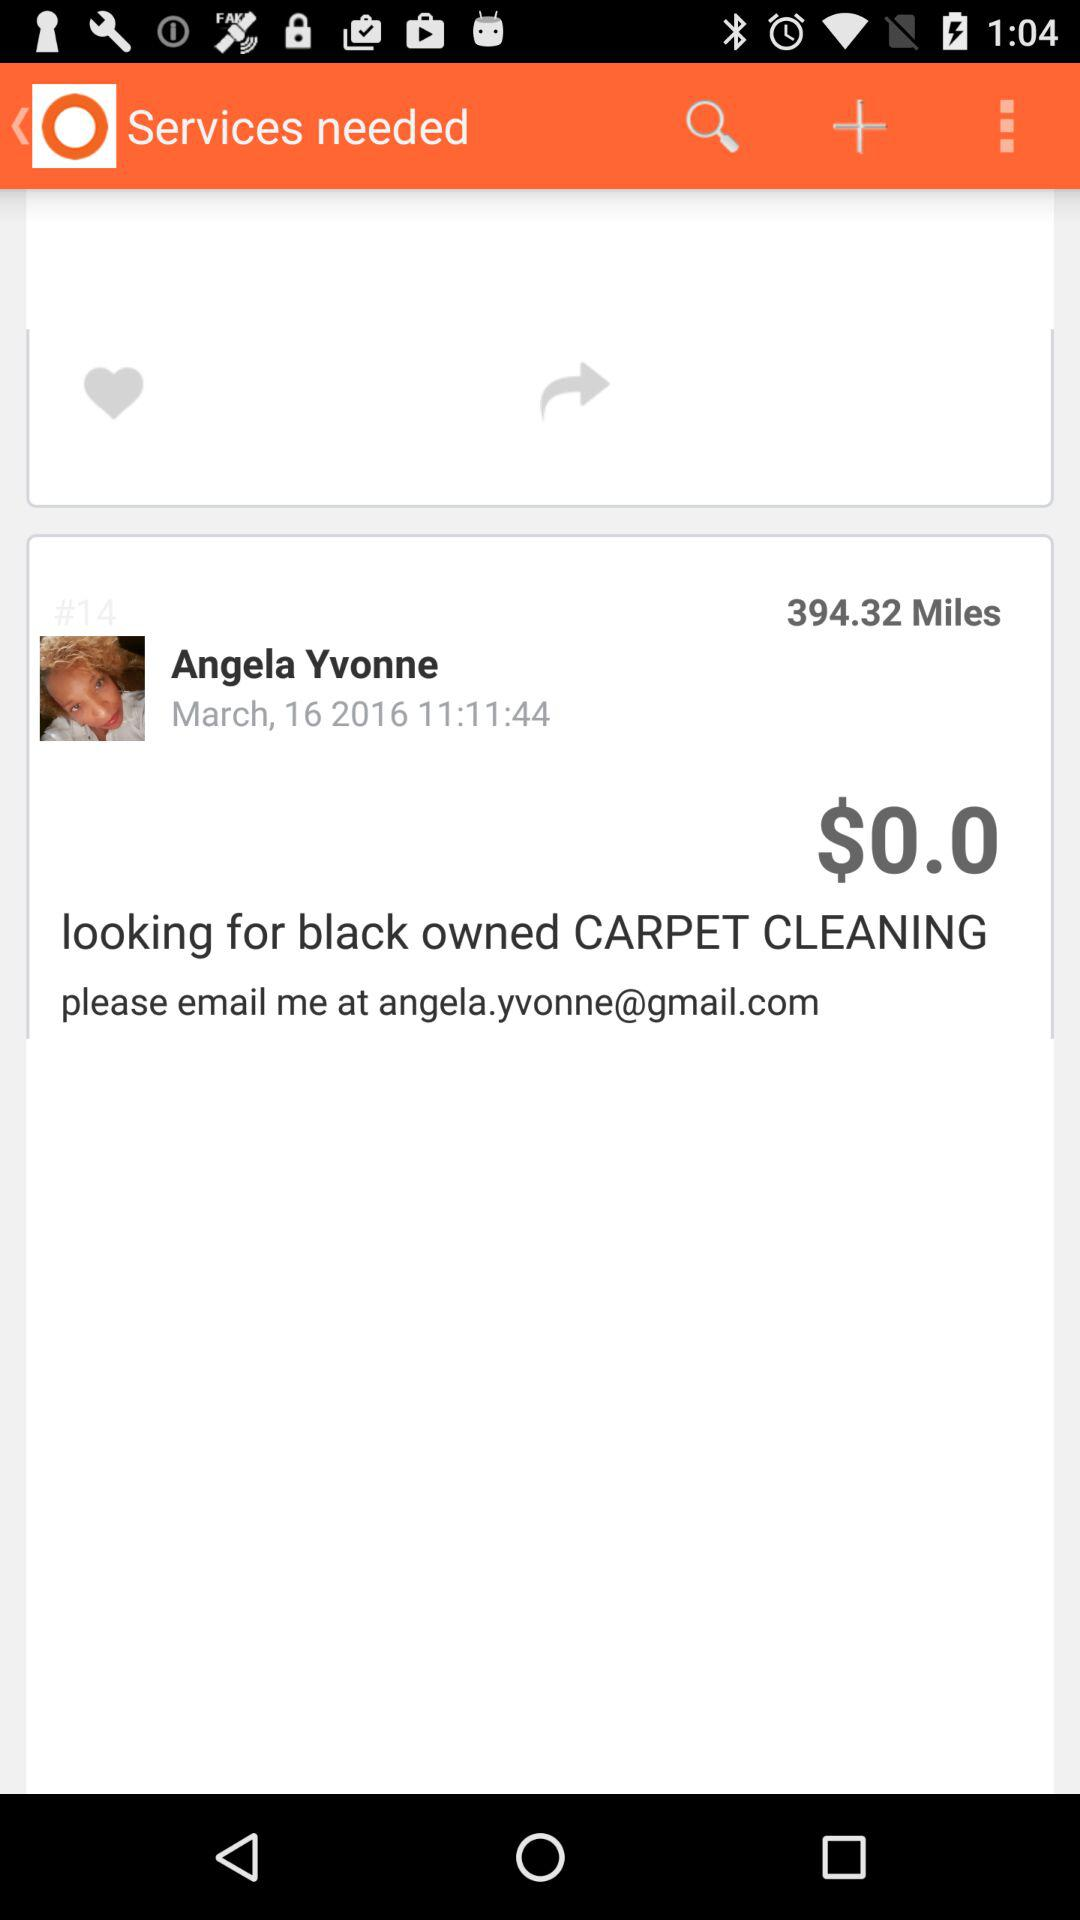What is the name of the user? The user name is Angela Yvonne. 